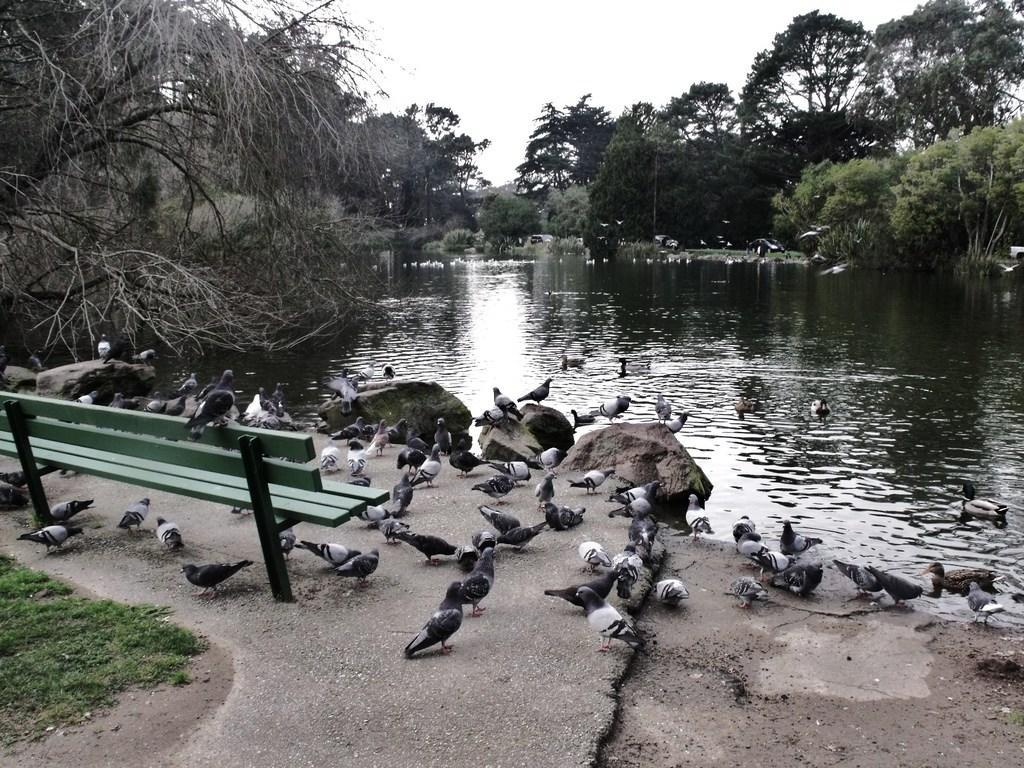How would you summarize this image in a sentence or two? In this image we can see some birds, there is bench which is in green color and in the background of the image there is some water, there are some trees and top of the image there is clear sky. 